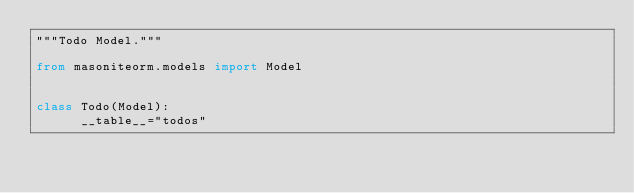Convert code to text. <code><loc_0><loc_0><loc_500><loc_500><_Python_>"""Todo Model."""

from masoniteorm.models import Model


class Todo(Model):
      __table__="todos"</code> 